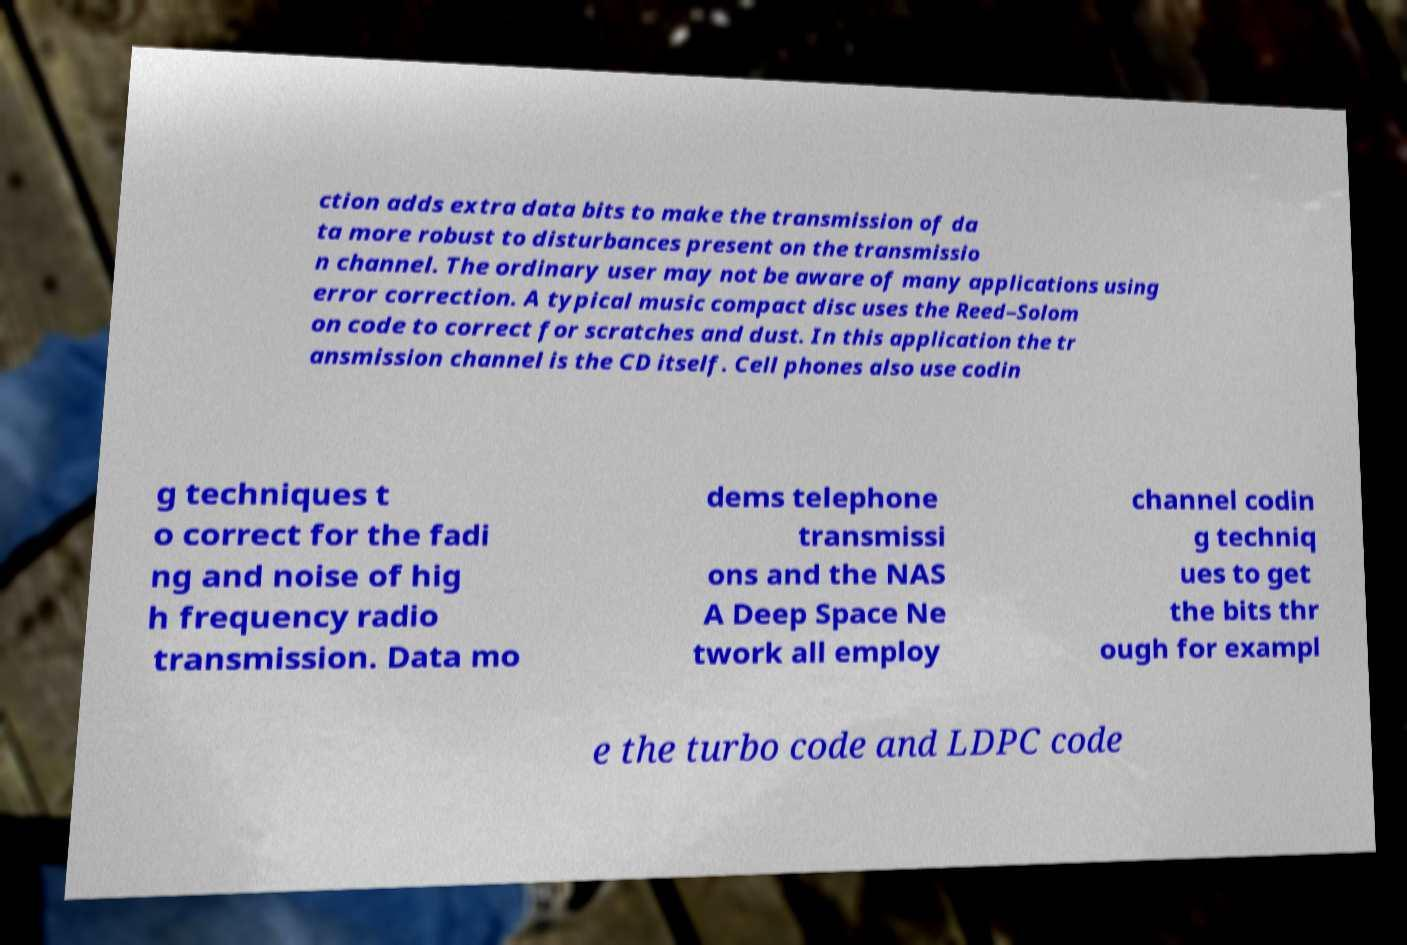I need the written content from this picture converted into text. Can you do that? ction adds extra data bits to make the transmission of da ta more robust to disturbances present on the transmissio n channel. The ordinary user may not be aware of many applications using error correction. A typical music compact disc uses the Reed–Solom on code to correct for scratches and dust. In this application the tr ansmission channel is the CD itself. Cell phones also use codin g techniques t o correct for the fadi ng and noise of hig h frequency radio transmission. Data mo dems telephone transmissi ons and the NAS A Deep Space Ne twork all employ channel codin g techniq ues to get the bits thr ough for exampl e the turbo code and LDPC code 